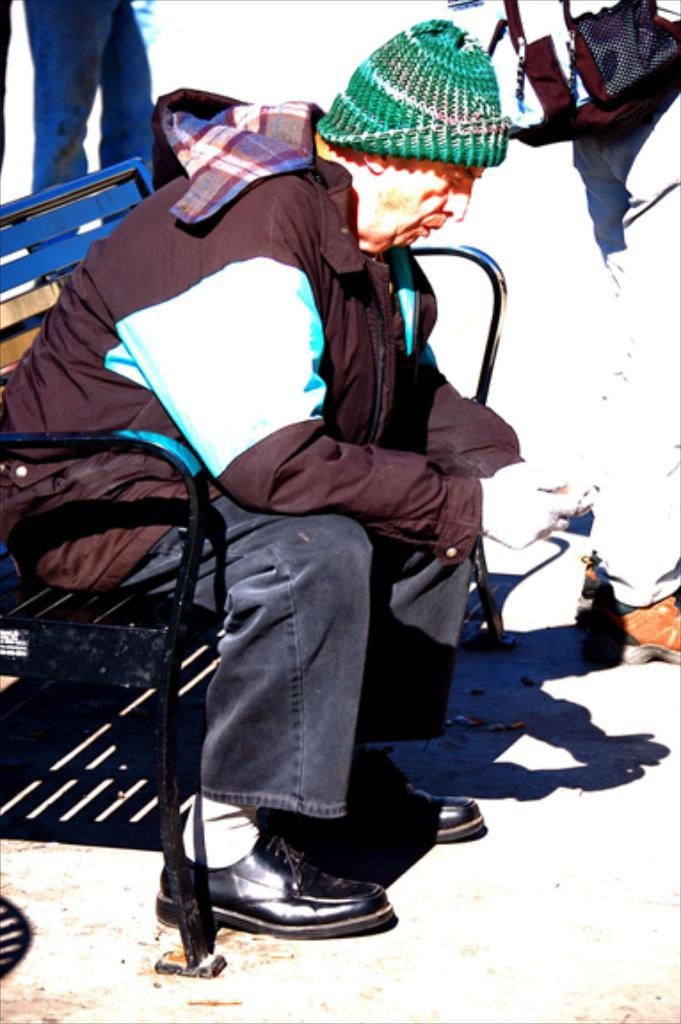What is the main subject of the image? The main subject of the image is an old person sitting on a bench. What can be seen on the old person's head? The old person is wearing a cap. What is located at the bottom of the image? There is a platform at the bottom of the image. Whose legs are visible in the image? Human legs are visible in the image. What object can be seen in the image besides the old person? There is a bag in the image. What type of tree is growing in the middle of the office in the image? There is no tree or office present in the image; it features an old person sitting on a bench with a bag and a platform. How many legs does the old person have in the image? The old person has two legs in the image, as is typical for humans. 